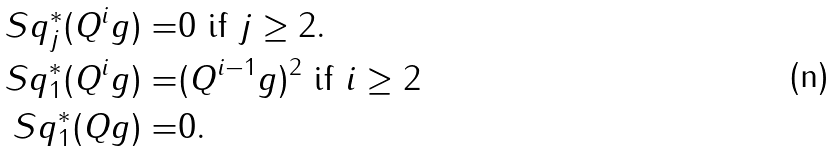Convert formula to latex. <formula><loc_0><loc_0><loc_500><loc_500>S q _ { j } ^ { * } ( Q ^ { i } g ) = & 0 \text { if } j \geq 2 . \\ S q _ { 1 } ^ { * } ( Q ^ { i } g ) = & ( Q ^ { i - 1 } g ) ^ { 2 } \text { if } i \geq 2 \\ S q _ { 1 } ^ { * } ( Q g ) = & 0 .</formula> 